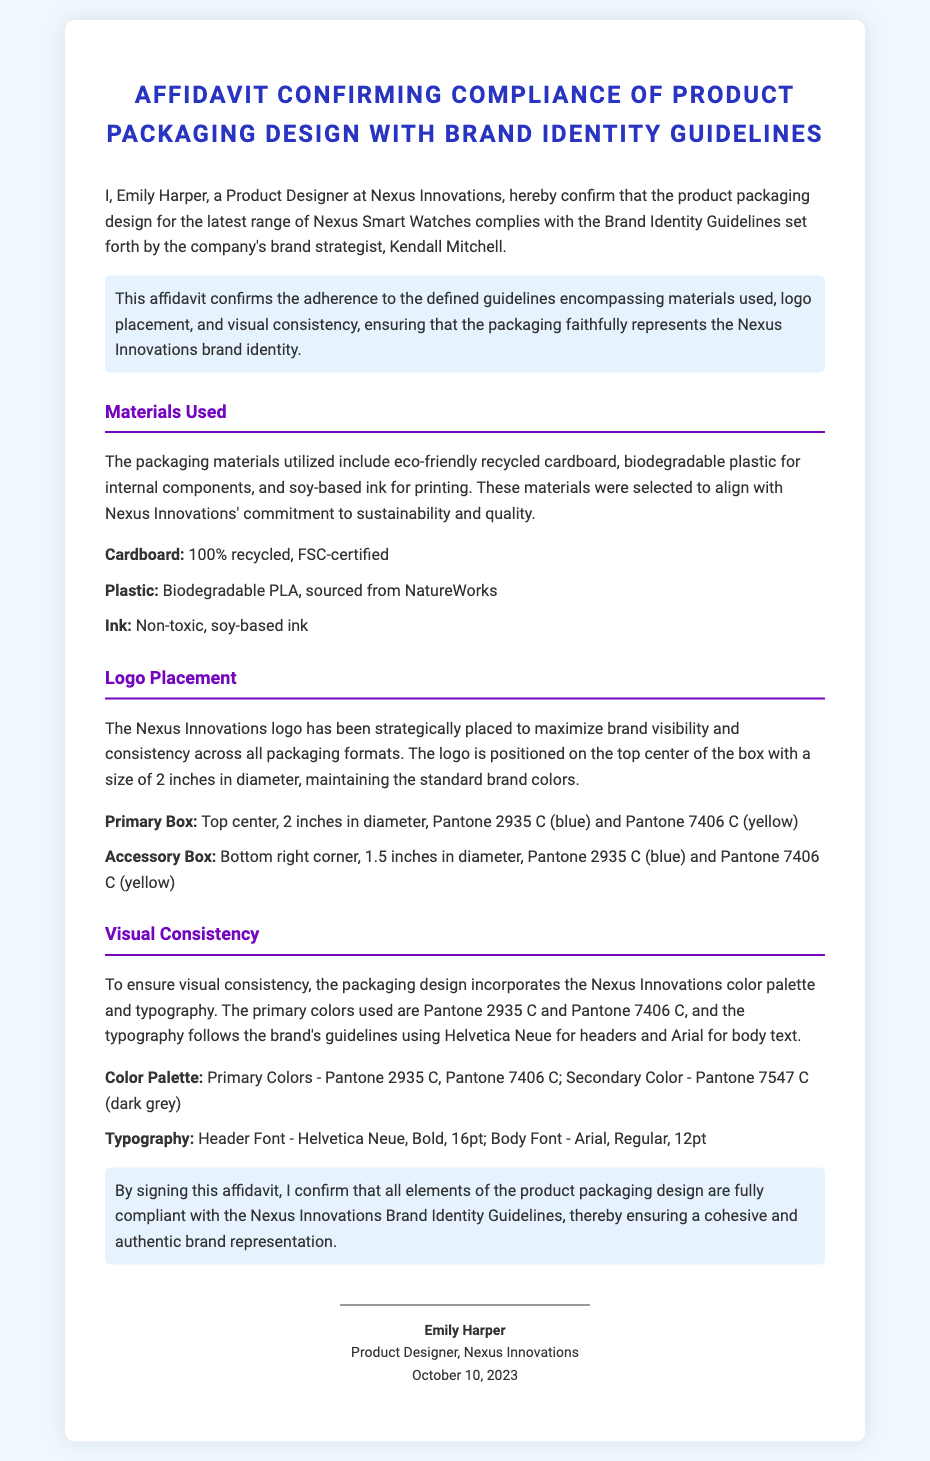What is the name of the Product Designer? The affidavit states the name of the product designer who signed it as Emily Harper.
Answer: Emily Harper What is the primary material used for the packaging? The document lists eco-friendly recycled cardboard as one of the materials utilized for packaging.
Answer: Recycled cardboard Where is the logo placed on the primary box? The affidavit indicates that the logo is positioned on the top center of the box.
Answer: Top center What is the date of the affidavit? The signature section of the document includes the date when Emily Harper signed the affidavit, which is October 10, 2023.
Answer: October 10, 2023 What colors are mentioned for the primary packaging design? The document specifies the primary colors as Pantone 2935 C and Pantone 7406 C.
Answer: Pantone 2935 C, Pantone 7406 C What certification is mentioned for the cardboard used? The affidavit states that the cardboard used is 100% recycled and FSC-certified.
Answer: FSC-certified What typography is used for headers? The document indicates that the header font used is Helvetica Neue.
Answer: Helvetica Neue How large is the logo on the accessory box? The affidavit notes that the logo on the accessory box has a diameter of 1.5 inches.
Answer: 1.5 inches What is the commitment reflected in the choice of materials? The affidavit highlights that the materials were selected to align with the commitment to sustainability.
Answer: Sustainability 